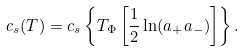Convert formula to latex. <formula><loc_0><loc_0><loc_500><loc_500>c _ { s } ( T ) = c _ { s } \left \{ T _ { \Phi } \left [ \frac { 1 } { 2 } \ln ( a _ { + } a _ { - } ) \right ] \right \} .</formula> 